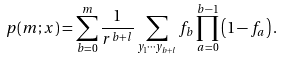<formula> <loc_0><loc_0><loc_500><loc_500>p ( m ; { x } ) = \sum _ { b = 0 } ^ { m } \frac { 1 } { r ^ { b + l } } \sum _ { y _ { 1 } \cdots y _ { b + l } } f _ { b } \prod _ { a = 0 } ^ { b - 1 } \left ( 1 - f _ { a } \right ) .</formula> 